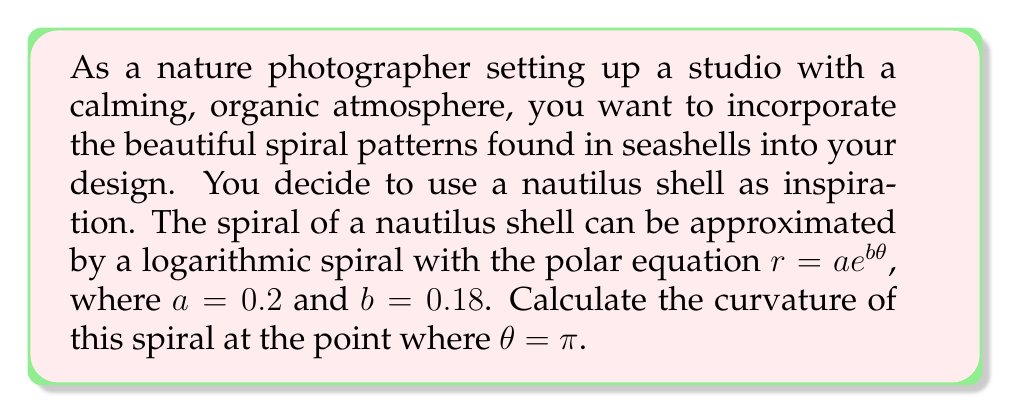Give your solution to this math problem. To calculate the curvature of a logarithmic spiral, we'll follow these steps:

1) The general formula for the curvature of a curve in polar coordinates is:

   $$\kappa = \frac{|r^2 + 2(r')^2 - rr''|}{(r^2 + (r')^2)^{3/2}}$$

2) For a logarithmic spiral $r = ae^{b\theta}$, we need to find $r'$ and $r''$:
   
   $r' = abe^{b\theta}$
   $r'' = ab^2e^{b\theta}$

3) Substituting these into the curvature formula:

   $$\kappa = \frac{|(ae^{b\theta})^2 + 2(abe^{b\theta})^2 - ae^{b\theta}(ab^2e^{b\theta})|}{((ae^{b\theta})^2 + (abe^{b\theta})^2)^{3/2}}$$

4) Simplifying:

   $$\kappa = \frac{|a^2e^{2b\theta}(1 + 2b^2 - b^2)|}{a^3e^{3b\theta}(1 + b^2)^{3/2}} = \frac{|1 + b^2|}{ae^{b\theta}(1 + b^2)^{3/2}}$$

5) Now, let's substitute the given values: $a = 0.2$, $b = 0.18$, and $\theta = \pi$:

   $$\kappa = \frac{|1 + 0.18^2|}{0.2e^{0.18\pi}(1 + 0.18^2)^{3/2}}$$

6) Calculate the result:

   $$\kappa \approx 1.7241$$

This curvature value represents how quickly the spiral is turning at the point where $\theta = \pi$. A higher value indicates a tighter curve, while a lower value indicates a more gradual curve.
Answer: The curvature of the logarithmic spiral approximating the nautilus shell at $\theta = \pi$ is approximately 1.7241. 